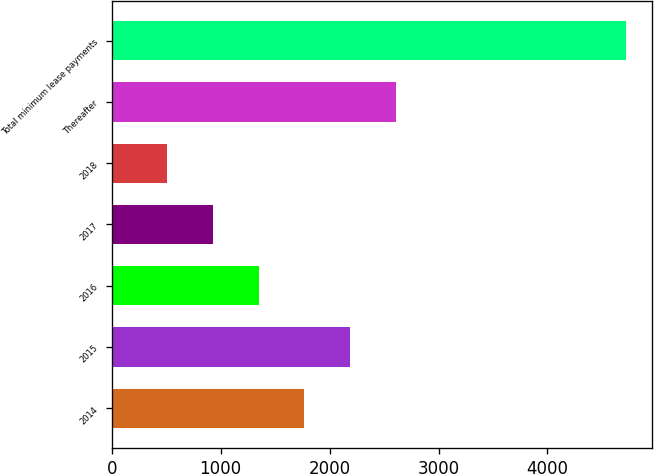<chart> <loc_0><loc_0><loc_500><loc_500><bar_chart><fcel>2014<fcel>2015<fcel>2016<fcel>2017<fcel>2018<fcel>Thereafter<fcel>Total minimum lease payments<nl><fcel>1769.8<fcel>2191.4<fcel>1348.2<fcel>926.6<fcel>505<fcel>2613<fcel>4721<nl></chart> 